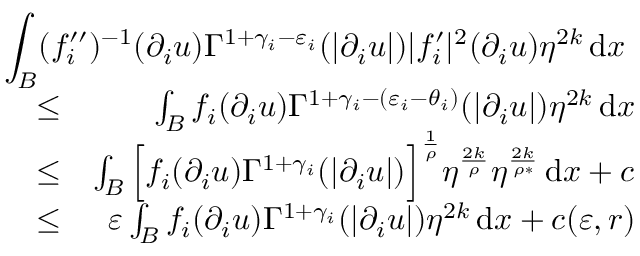<formula> <loc_0><loc_0><loc_500><loc_500>\begin{array} { r l r } { { \int _ { B } ( f _ { i } ^ { \prime \prime } ) ^ { - 1 } ( \partial _ { i } u ) \Gamma ^ { 1 + \gamma _ { i } - \varepsilon _ { i } } ( | \partial _ { i } u | ) | f _ { i } ^ { \prime } | ^ { 2 } ( \partial _ { i } u ) \eta ^ { 2 k } \, d x } } \\ & { \leq } & { \int _ { B } f _ { i } ( \partial _ { i } u ) \Gamma ^ { 1 + \gamma _ { i } - ( \varepsilon _ { i } - \theta _ { i } ) } ( | \partial _ { i } u | ) \eta ^ { 2 k } \, d x } \\ & { \leq } & { \int _ { B } \left [ f _ { i } ( \partial _ { i } u ) \Gamma ^ { 1 + \gamma _ { i } } ( | \partial _ { i } u | ) \right ] ^ { \frac { 1 } { \rho } } \eta ^ { \frac { 2 k } { \rho } } \eta ^ { \frac { 2 k } { \rho * } } \, d x + c } \\ & { \leq } & { \varepsilon \int _ { B } f _ { i } ( \partial _ { i } u ) \Gamma ^ { 1 + \gamma _ { i } } ( | \partial _ { i } u | ) \eta ^ { 2 k } \, d x + c ( \varepsilon , r ) } \end{array}</formula> 